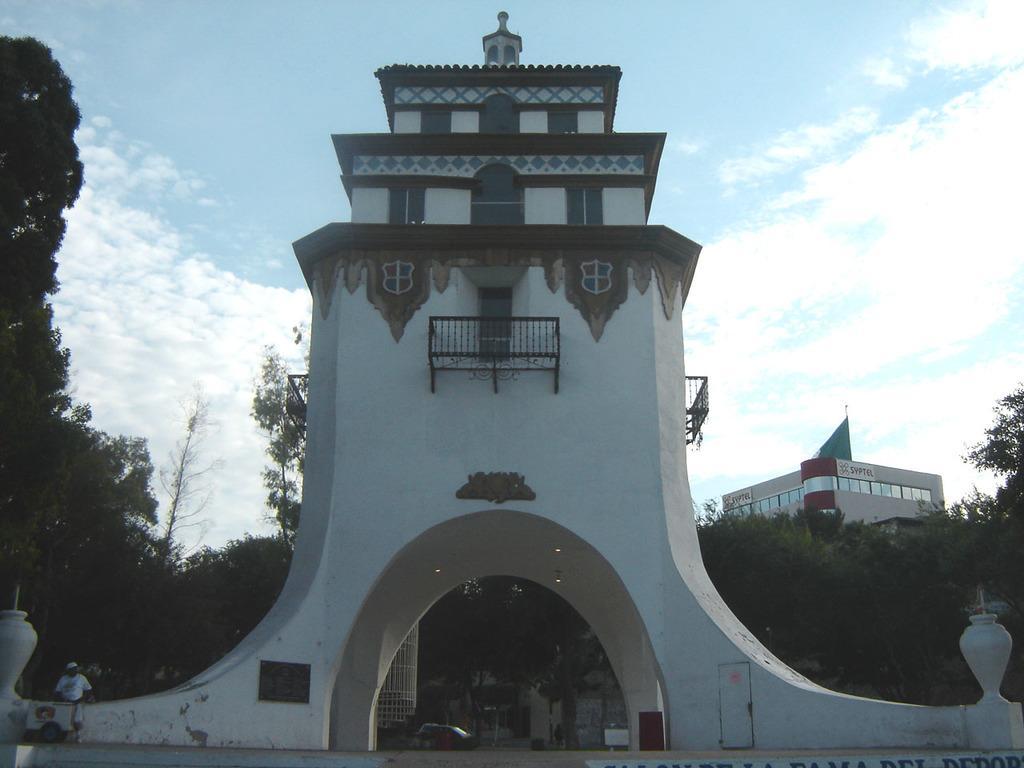How would you summarize this image in a sentence or two? In this image we can see the arch wall, a person standing here, vehicles moving on the road, trees, buildings and the sky with clouds in the background. 